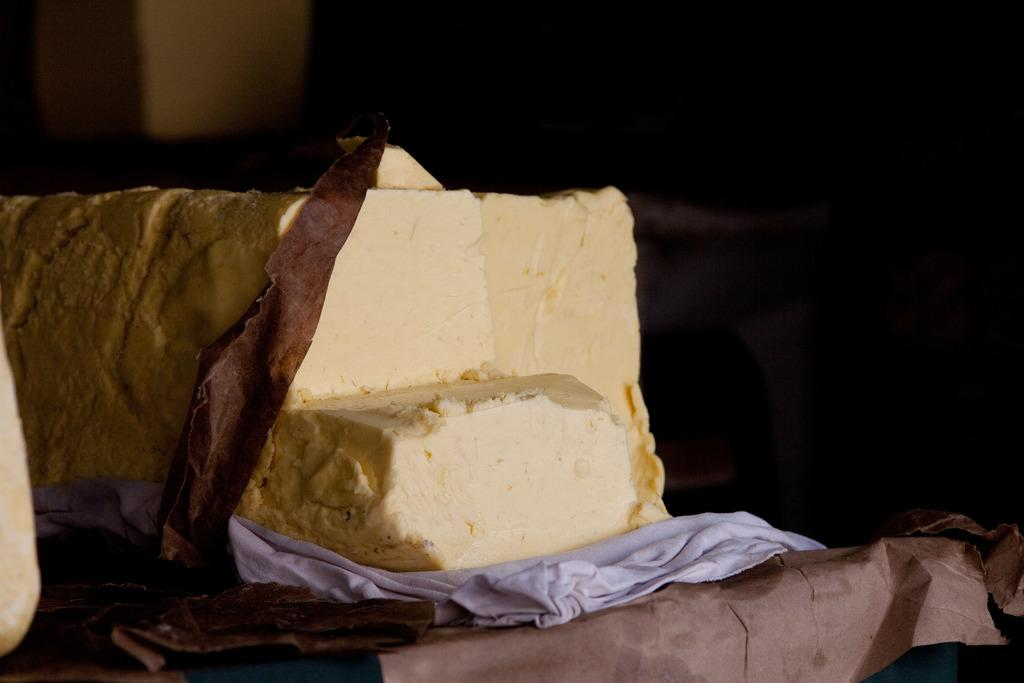What type of food is visible in the image? There is a block of cheese in the image. What else can be seen in the image besides the cheese? There is a cloth on an object in the image. How would you describe the overall lighting in the image? The background of the image is dark. What type of spark can be seen coming from the cheese in the image? There is no spark present in the image; it is a block of cheese without any visible sparks. 